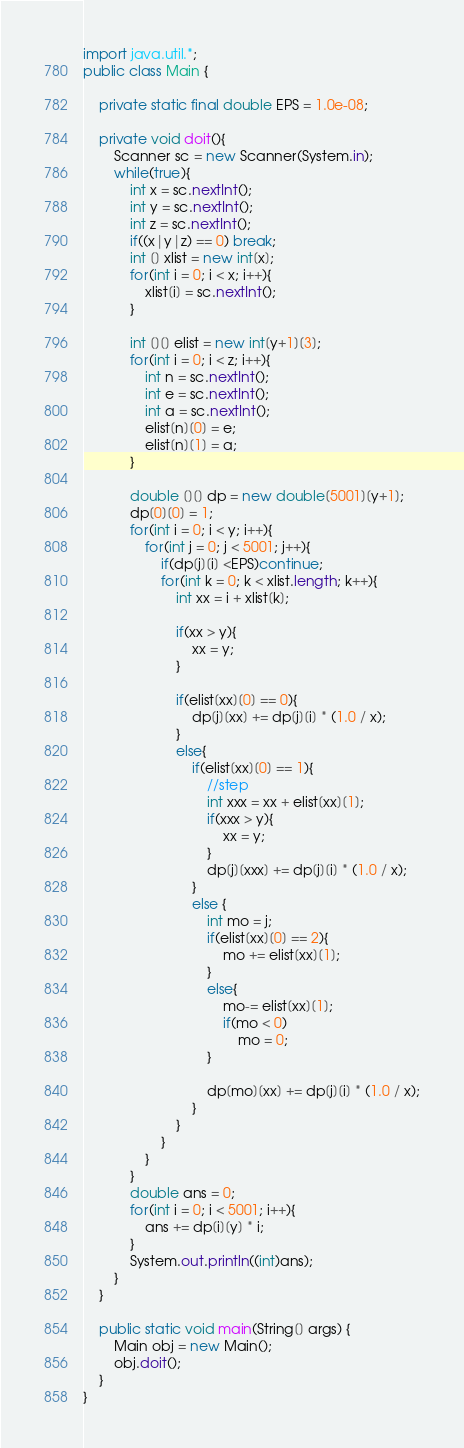Convert code to text. <code><loc_0><loc_0><loc_500><loc_500><_Java_>
import java.util.*;
public class Main {
	
	private static final double EPS = 1.0e-08;

	private void doit(){
		Scanner sc = new Scanner(System.in);
		while(true){
			int x = sc.nextInt();
			int y = sc.nextInt();
			int z = sc.nextInt();
			if((x|y|z) == 0) break;
			int [] xlist = new int[x];
			for(int i = 0; i < x; i++){
				xlist[i] = sc.nextInt();
			}
			
			int [][] elist = new int[y+1][3];
			for(int i = 0; i < z; i++){
				int n = sc.nextInt();
				int e = sc.nextInt();
				int a = sc.nextInt();
				elist[n][0] = e;
				elist[n][1] = a;
			}
			
			double [][] dp = new double[5001][y+1];
			dp[0][0] = 1;
			for(int i = 0; i < y; i++){
				for(int j = 0; j < 5001; j++){
					if(dp[j][i] <EPS)continue;
					for(int k = 0; k < xlist.length; k++){
						int xx = i + xlist[k];
						
						if(xx > y){
							xx = y;
						}
						
						if(elist[xx][0] == 0){
							dp[j][xx] += dp[j][i] * (1.0 / x);
						}
						else{
							if(elist[xx][0] == 1){
								//step
								int xxx = xx + elist[xx][1];
								if(xxx > y){
									xx = y;
								}
								dp[j][xxx] += dp[j][i] * (1.0 / x);
							}
							else {
								int mo = j;
								if(elist[xx][0] == 2){
									mo += elist[xx][1];
								}
								else{
									mo-= elist[xx][1];
									if(mo < 0)
										mo = 0;
								}
								
								dp[mo][xx] += dp[j][i] * (1.0 / x);
							}
						}
					}
				}
			}
			double ans = 0;
			for(int i = 0; i < 5001; i++){
				ans += dp[i][y] * i;
			}
			System.out.println((int)ans);
		}
	}
	
	public static void main(String[] args) {
		Main obj = new Main();
		obj.doit();
	}
}</code> 